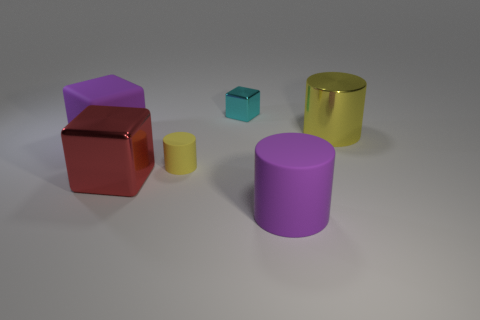How many objects are either tiny cyan cubes or big purple rubber blocks?
Your answer should be compact. 2. How many cyan blocks are made of the same material as the tiny yellow cylinder?
Your response must be concise. 0. What size is the cyan shiny object that is the same shape as the red shiny object?
Make the answer very short. Small. Are there any large metal cubes behind the big matte cube?
Provide a short and direct response. No. What material is the red block?
Provide a short and direct response. Metal. There is a big cylinder that is in front of the purple matte block; does it have the same color as the tiny metal block?
Make the answer very short. No. Is there anything else that has the same shape as the yellow rubber thing?
Give a very brief answer. Yes. The other metal thing that is the same shape as the tiny yellow thing is what color?
Provide a succinct answer. Yellow. There is a yellow cylinder to the left of the tiny cyan block; what is it made of?
Make the answer very short. Rubber. The small metal object has what color?
Make the answer very short. Cyan. 